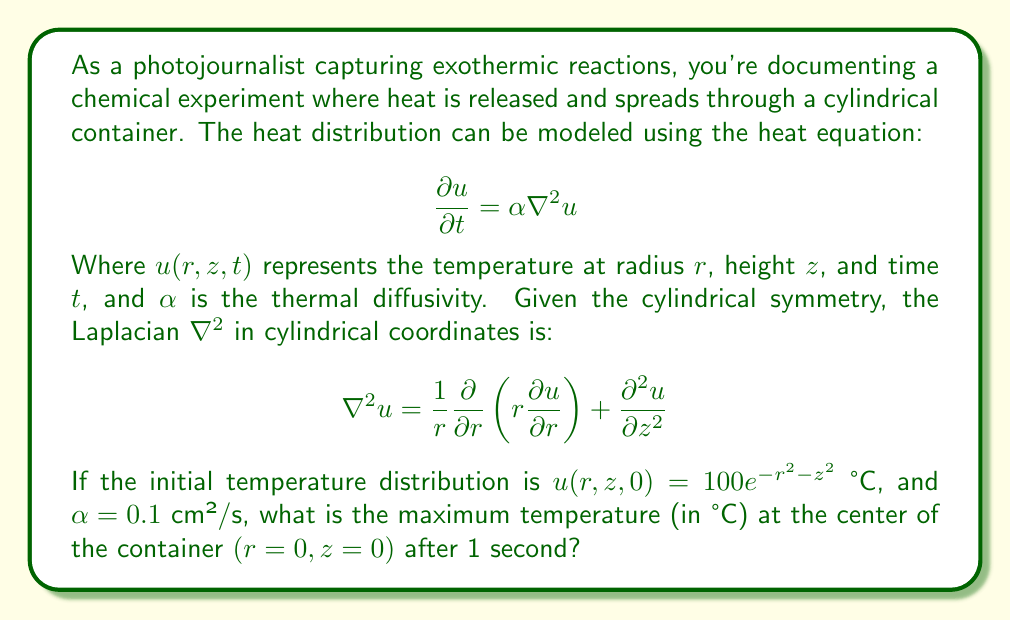Help me with this question. To solve this problem, we need to follow these steps:

1) First, we recognize that the given initial condition $u(r,z,0) = 100e^{-r^2-z^2}$ is already in a separable form that satisfies the heat equation.

2) The general solution for the heat equation in cylindrical coordinates with this initial condition is:

   $$u(r,z,t) = 100e^{-r^2-z^2-2\alpha t}$$

3) We need to evaluate this at the center $(r=0, z=0)$ after 1 second $(t=1)$. We're also given that $\alpha = 0.1$ cm²/s.

4) Substituting these values:

   $$u(0,0,1) = 100e^{-0^2-0^2-2(0.1)(1)}$$
   
   $$= 100e^{-0.2}$$

5) Calculate this value:

   $$100e^{-0.2} \approx 81.87$$

Therefore, the maximum temperature at the center of the container after 1 second is approximately 81.87 °C.
Answer: 81.87 °C 